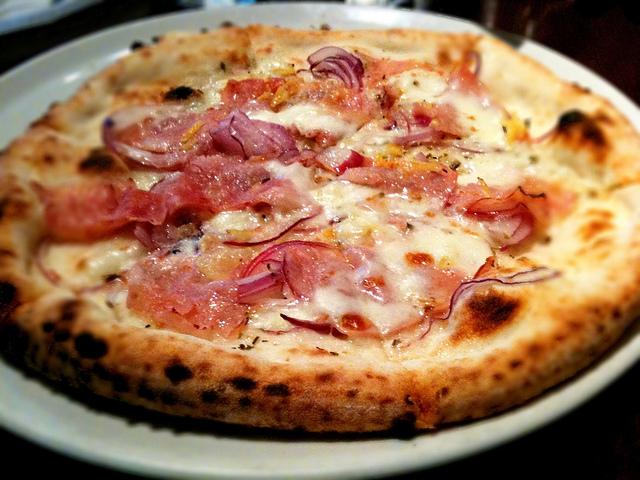Is the pizza sliced?
Keep it brief. No. Is this vegetarian?
Be succinct. No. What kind of meat is on the pizza?
Answer briefly. Ham. What kind of onions are on the pizza?
Short answer required. Red. Does this look like a small or large pizza?
Be succinct. Small. What kind of toppings are on this pizza?
Quick response, please. Onions and ham. 